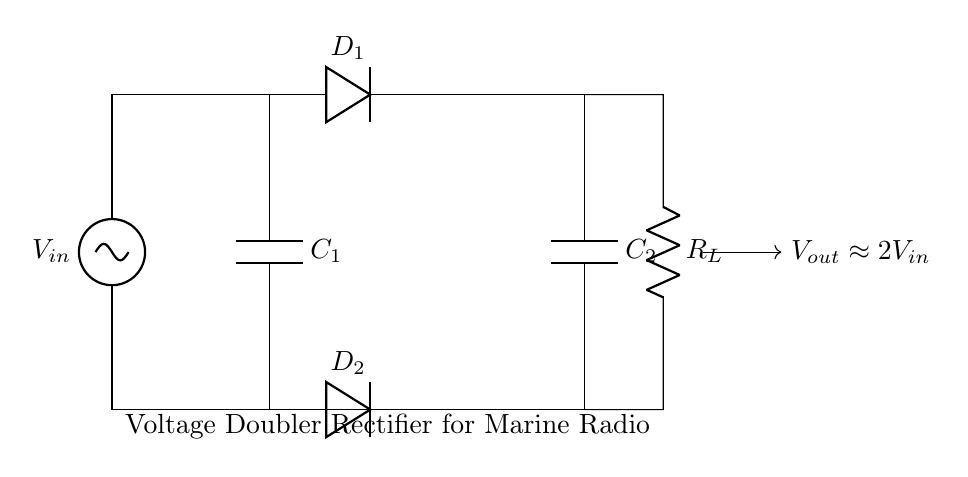What is the input voltage in this circuit? The input voltage, denoted as V_in, is the voltage supplied to the circuit and is represented by the source labeled V_in in the diagram.
Answer: V_in What type of components are used in this circuit? The circuit consists of a voltage source, capacitors, diodes, and a resistor, specifically a voltage source (V_in), two capacitors (C_1 and C_2), two diodes (D_1 and D_2), and a load resistor (R_L).
Answer: Voltage source, capacitors, diodes, resistor What is the purpose of capacitors C_1 and C_2? Capacitors C_1 and C_2 store electrical energy and help to smooth out the output voltage, effectively increasing the voltage supplied to the load.
Answer: To store energy and smooth output voltage How is the output voltage related to the input voltage? The output voltage V_out is approximately equal to twice the input voltage V_in, which is illustrated by the label next to the output that states V_out is roughly 2V_in.
Answer: Approximately 2V_in What function do the diodes D_1 and D_2 serve in this circuit? The diodes D_1 and D_2 allow current to flow in one direction only, rectifying the AC input voltage to produce a DC output voltage suitable for the marine radio equipment.
Answer: Rectification What is the role of the load resistor R_L? The load resistor R_L represents the load connected to the circuit, simulating the power consumption of the marine radio equipment, which can be powered by the rectified voltage output.
Answer: To simulate the load for radio equipment What happens to the output voltage if the input voltage increases? If the input voltage V_in increases, the output voltage V_out will also increase, approximately doubling the input voltage as per the relationship indicated in the circuit.
Answer: Output voltage increases 